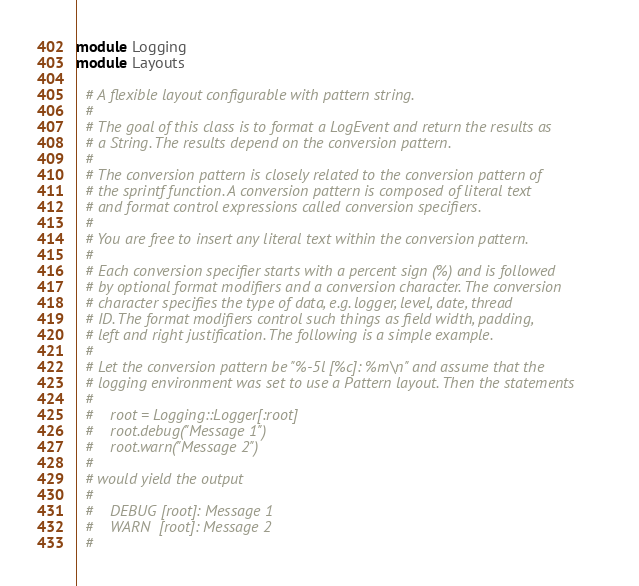Convert code to text. <code><loc_0><loc_0><loc_500><loc_500><_Ruby_>
module Logging
module Layouts

  # A flexible layout configurable with pattern string.
  #
  # The goal of this class is to format a LogEvent and return the results as
  # a String. The results depend on the conversion pattern.
  #
  # The conversion pattern is closely related to the conversion pattern of
  # the sprintf function. A conversion pattern is composed of literal text
  # and format control expressions called conversion specifiers.
  #
  # You are free to insert any literal text within the conversion pattern.
  #
  # Each conversion specifier starts with a percent sign (%) and is followed
  # by optional format modifiers and a conversion character. The conversion
  # character specifies the type of data, e.g. logger, level, date, thread
  # ID. The format modifiers control such things as field width, padding,
  # left and right justification. The following is a simple example.
  #
  # Let the conversion pattern be "%-5l [%c]: %m\n" and assume that the
  # logging environment was set to use a Pattern layout. Then the statements
  #
  #    root = Logging::Logger[:root]
  #    root.debug("Message 1")
  #    root.warn("Message 2")
  #
  # would yield the output
  #
  #    DEBUG [root]: Message 1
  #    WARN  [root]: Message 2
  #</code> 